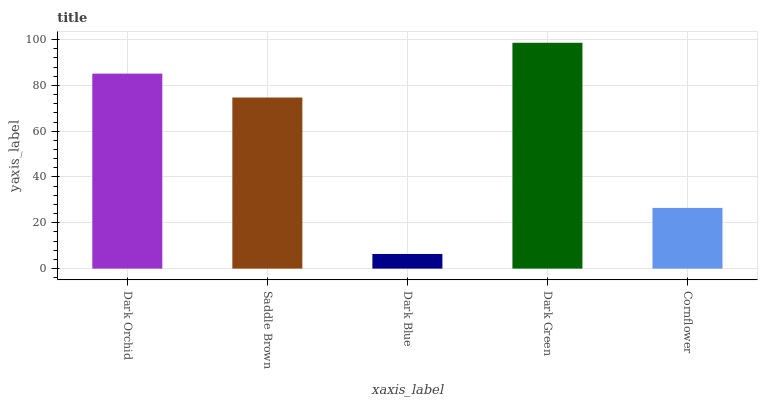Is Dark Blue the minimum?
Answer yes or no. Yes. Is Dark Green the maximum?
Answer yes or no. Yes. Is Saddle Brown the minimum?
Answer yes or no. No. Is Saddle Brown the maximum?
Answer yes or no. No. Is Dark Orchid greater than Saddle Brown?
Answer yes or no. Yes. Is Saddle Brown less than Dark Orchid?
Answer yes or no. Yes. Is Saddle Brown greater than Dark Orchid?
Answer yes or no. No. Is Dark Orchid less than Saddle Brown?
Answer yes or no. No. Is Saddle Brown the high median?
Answer yes or no. Yes. Is Saddle Brown the low median?
Answer yes or no. Yes. Is Cornflower the high median?
Answer yes or no. No. Is Dark Green the low median?
Answer yes or no. No. 